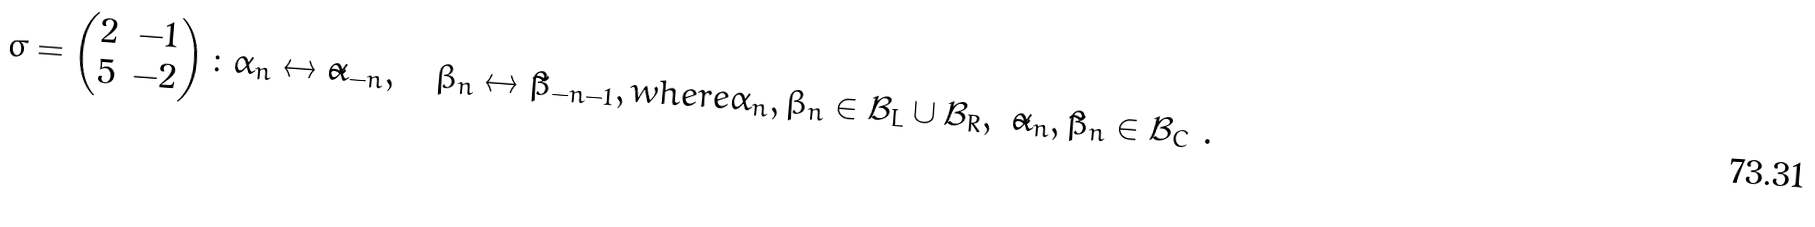<formula> <loc_0><loc_0><loc_500><loc_500>\sigma = \begin{pmatrix} 2 & - 1 \\ 5 & - 2 \end{pmatrix} \colon \alpha _ { n } \leftrightarrow \tilde { \alpha } _ { - n } , \quad \beta _ { n } \leftrightarrow \tilde { \beta } _ { - n - 1 } , w h e r e \alpha _ { n } , \beta _ { n } \in \mathcal { B } _ { L } \cup \mathcal { B } _ { R } , \ \tilde { \alpha } _ { n } , \tilde { \beta } _ { n } \in \mathcal { B } _ { C } \ .</formula> 